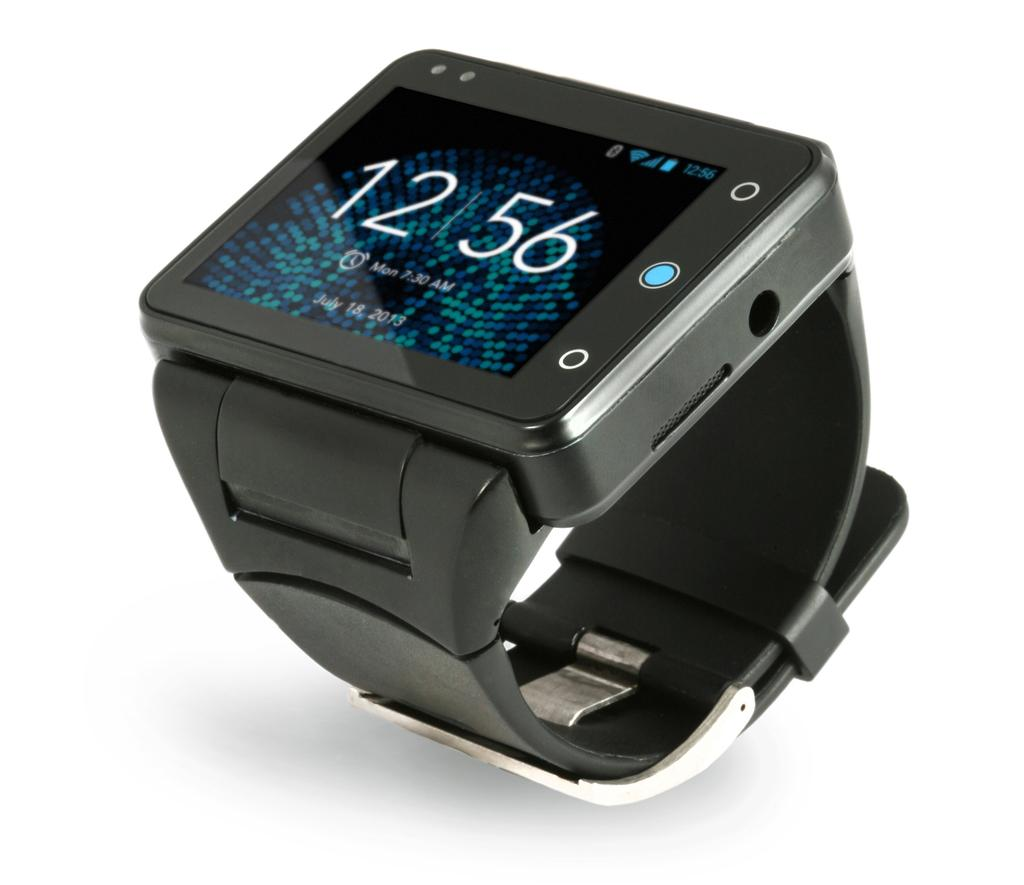<image>
Offer a succinct explanation of the picture presented. A smart watch is displaying the time as 12:56 on July 18, 2013. 